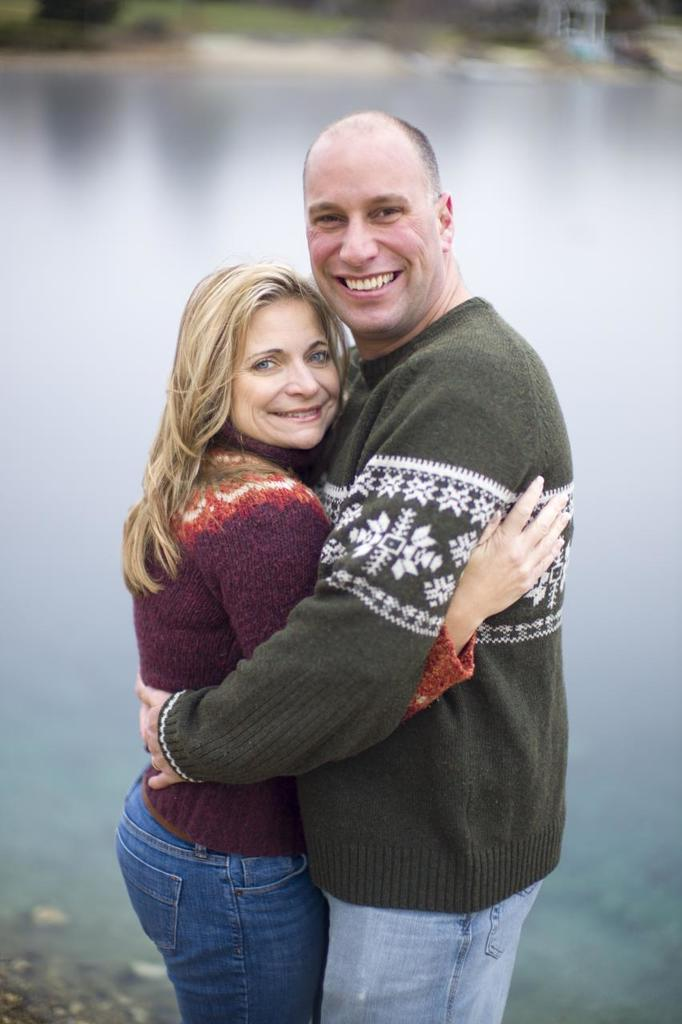Who is present in the image? There is a woman and a man in the image. What are the woman and the man wearing? Both the woman and the man are wearing sweaters. What are the woman and the man doing in the image? The woman and the man are standing and smiling. How is the background of the image? The background of the image is slightly blurred. What can be seen in the background of the image? Water is visible in the background of the image. How many bananas are being compared by the woman and the man in the image? There are no bananas present in the image, and no comparison is being made. What type of sea creature can be seen swimming in the water in the background of the image? There are no sea creatures visible in the image; only water is present in the background. 